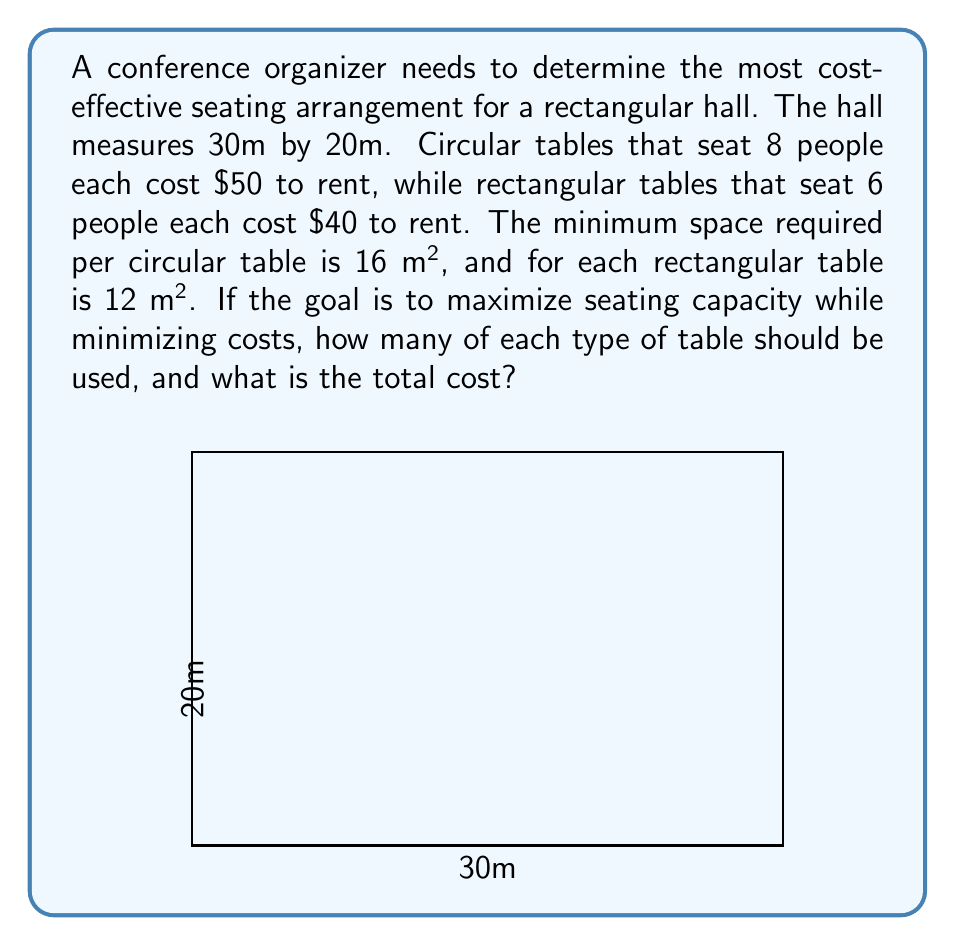Can you answer this question? Let's approach this step-by-step:

1) Let $x$ be the number of circular tables and $y$ be the number of rectangular tables.

2) The total area of the hall is $30m \times 20m = 600m²$.

3) The area constraint can be expressed as:
   $$16x + 12y \leq 600$$

4) The total number of people seated will be:
   $$8x + 6y$$

5) The total cost will be:
   $$50x + 40y$$

6) Our objective is to maximize seating while minimizing cost. We can express this as maximizing the ratio of people seated to cost:
   $$\text{maximize } \frac{8x + 6y}{50x + 40y}$$

7) This is a fractional programming problem. We can solve it using the following steps:
   a) Find the extreme points of the feasible region
   b) Evaluate the objective function at these points

8) The extreme points are:
   (0,0), (37,0), (0,50), and (25,25)

9) Evaluating the objective function at these points:
   (0,0): undefined
   (37,0): $\frac{296}{1850} \approx 0.16$
   (0,50): $\frac{300}{2000} = 0.15$
   (25,25): $\frac{350}{2250} \approx 0.156$

10) The maximum value is at (37,0), which means using only circular tables.

11) However, we need to round down to 37 tables due to space constraints.

12) Total cost: $37 \times $50 = $1850
Answer: 37 circular tables, 0 rectangular tables; Total cost: $1850 